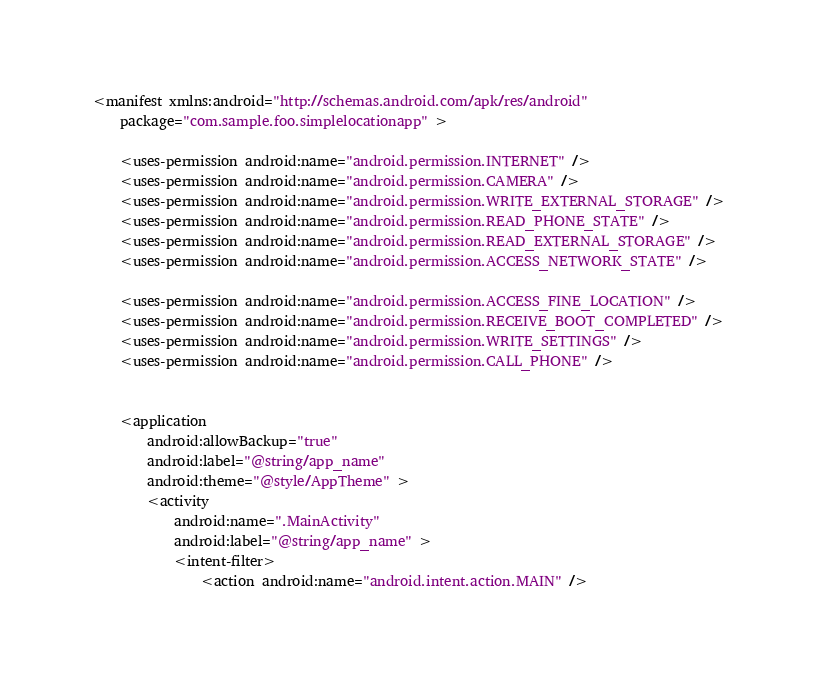Convert code to text. <code><loc_0><loc_0><loc_500><loc_500><_XML_><manifest xmlns:android="http://schemas.android.com/apk/res/android"
    package="com.sample.foo.simplelocationapp" >

    <uses-permission android:name="android.permission.INTERNET" />
    <uses-permission android:name="android.permission.CAMERA" />
    <uses-permission android:name="android.permission.WRITE_EXTERNAL_STORAGE" />
    <uses-permission android:name="android.permission.READ_PHONE_STATE" />
    <uses-permission android:name="android.permission.READ_EXTERNAL_STORAGE" />
    <uses-permission android:name="android.permission.ACCESS_NETWORK_STATE" />

    <uses-permission android:name="android.permission.ACCESS_FINE_LOCATION" />
    <uses-permission android:name="android.permission.RECEIVE_BOOT_COMPLETED" />
    <uses-permission android:name="android.permission.WRITE_SETTINGS" />
    <uses-permission android:name="android.permission.CALL_PHONE" />


    <application
        android:allowBackup="true"
        android:label="@string/app_name"
        android:theme="@style/AppTheme" >
        <activity
            android:name=".MainActivity"
            android:label="@string/app_name" >
            <intent-filter>
                <action android:name="android.intent.action.MAIN" />
</code> 